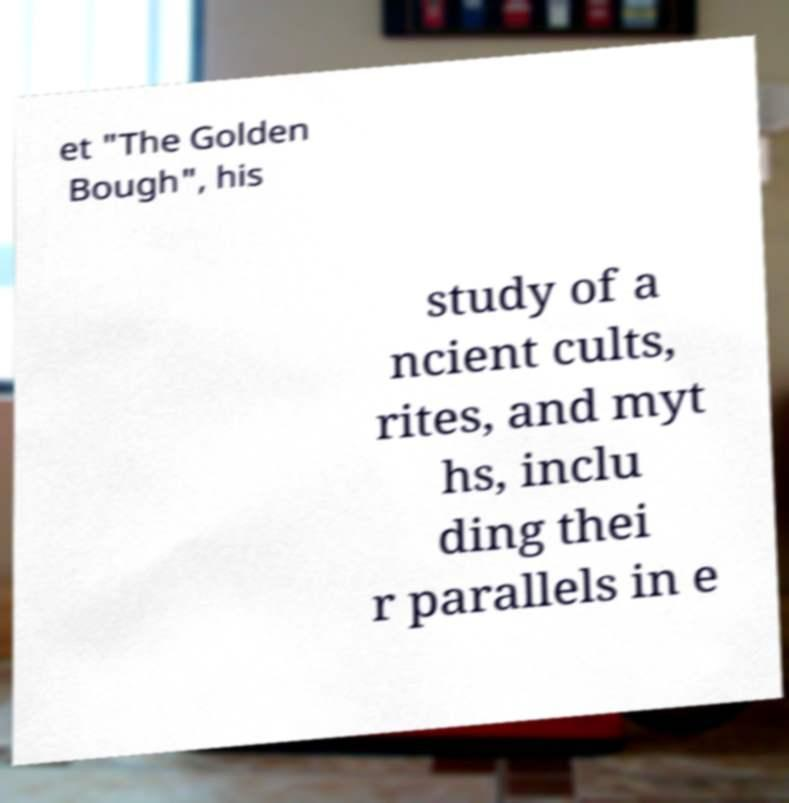Could you assist in decoding the text presented in this image and type it out clearly? et "The Golden Bough", his study of a ncient cults, rites, and myt hs, inclu ding thei r parallels in e 